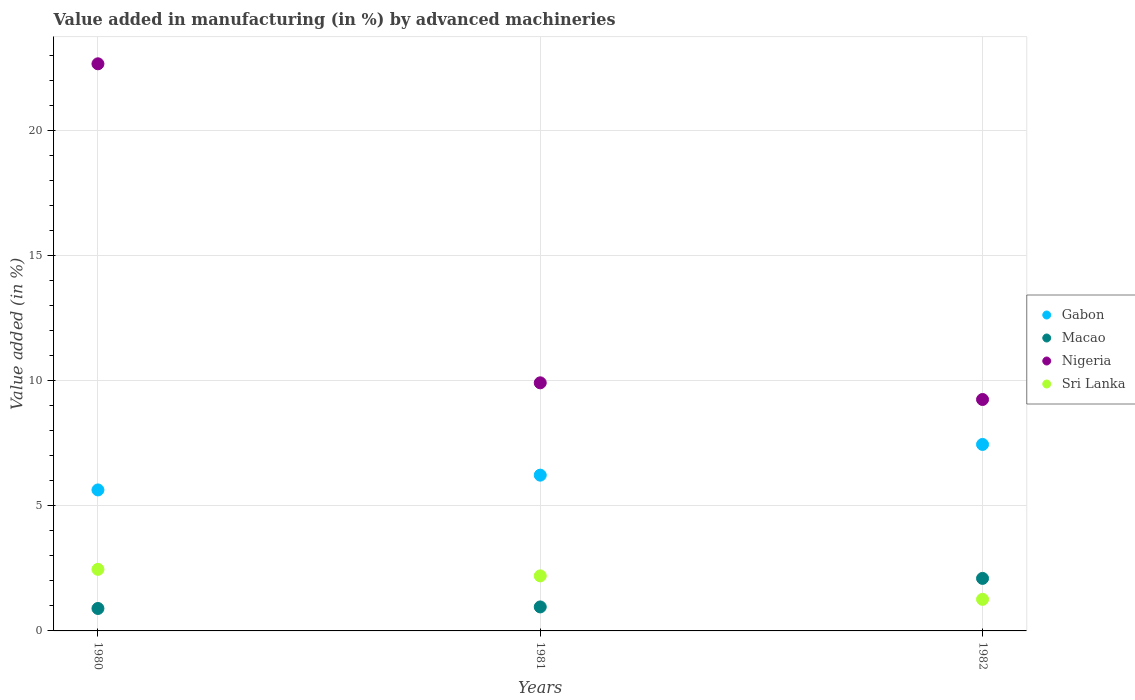How many different coloured dotlines are there?
Offer a terse response. 4. What is the percentage of value added in manufacturing by advanced machineries in Nigeria in 1981?
Provide a short and direct response. 9.91. Across all years, what is the maximum percentage of value added in manufacturing by advanced machineries in Gabon?
Offer a very short reply. 7.45. Across all years, what is the minimum percentage of value added in manufacturing by advanced machineries in Nigeria?
Keep it short and to the point. 9.24. What is the total percentage of value added in manufacturing by advanced machineries in Gabon in the graph?
Offer a terse response. 19.3. What is the difference between the percentage of value added in manufacturing by advanced machineries in Sri Lanka in 1980 and that in 1982?
Your answer should be compact. 1.2. What is the difference between the percentage of value added in manufacturing by advanced machineries in Sri Lanka in 1980 and the percentage of value added in manufacturing by advanced machineries in Macao in 1982?
Your answer should be compact. 0.36. What is the average percentage of value added in manufacturing by advanced machineries in Gabon per year?
Offer a very short reply. 6.43. In the year 1982, what is the difference between the percentage of value added in manufacturing by advanced machineries in Nigeria and percentage of value added in manufacturing by advanced machineries in Macao?
Keep it short and to the point. 7.15. In how many years, is the percentage of value added in manufacturing by advanced machineries in Nigeria greater than 1 %?
Offer a terse response. 3. What is the ratio of the percentage of value added in manufacturing by advanced machineries in Gabon in 1980 to that in 1982?
Offer a very short reply. 0.76. Is the percentage of value added in manufacturing by advanced machineries in Macao in 1981 less than that in 1982?
Give a very brief answer. Yes. What is the difference between the highest and the second highest percentage of value added in manufacturing by advanced machineries in Sri Lanka?
Ensure brevity in your answer.  0.26. What is the difference between the highest and the lowest percentage of value added in manufacturing by advanced machineries in Sri Lanka?
Make the answer very short. 1.2. In how many years, is the percentage of value added in manufacturing by advanced machineries in Macao greater than the average percentage of value added in manufacturing by advanced machineries in Macao taken over all years?
Provide a succinct answer. 1. Is the sum of the percentage of value added in manufacturing by advanced machineries in Macao in 1981 and 1982 greater than the maximum percentage of value added in manufacturing by advanced machineries in Gabon across all years?
Keep it short and to the point. No. Is it the case that in every year, the sum of the percentage of value added in manufacturing by advanced machineries in Gabon and percentage of value added in manufacturing by advanced machineries in Sri Lanka  is greater than the sum of percentage of value added in manufacturing by advanced machineries in Macao and percentage of value added in manufacturing by advanced machineries in Nigeria?
Offer a very short reply. Yes. Is the percentage of value added in manufacturing by advanced machineries in Macao strictly greater than the percentage of value added in manufacturing by advanced machineries in Nigeria over the years?
Keep it short and to the point. No. Is the percentage of value added in manufacturing by advanced machineries in Macao strictly less than the percentage of value added in manufacturing by advanced machineries in Nigeria over the years?
Offer a very short reply. Yes. How many years are there in the graph?
Keep it short and to the point. 3. Does the graph contain any zero values?
Make the answer very short. No. Where does the legend appear in the graph?
Ensure brevity in your answer.  Center right. How many legend labels are there?
Keep it short and to the point. 4. What is the title of the graph?
Keep it short and to the point. Value added in manufacturing (in %) by advanced machineries. What is the label or title of the X-axis?
Provide a short and direct response. Years. What is the label or title of the Y-axis?
Your answer should be very brief. Value added (in %). What is the Value added (in %) of Gabon in 1980?
Offer a very short reply. 5.63. What is the Value added (in %) in Macao in 1980?
Provide a short and direct response. 0.9. What is the Value added (in %) in Nigeria in 1980?
Your answer should be very brief. 22.65. What is the Value added (in %) in Sri Lanka in 1980?
Provide a succinct answer. 2.46. What is the Value added (in %) of Gabon in 1981?
Your response must be concise. 6.22. What is the Value added (in %) of Macao in 1981?
Your answer should be compact. 0.96. What is the Value added (in %) in Nigeria in 1981?
Provide a short and direct response. 9.91. What is the Value added (in %) of Sri Lanka in 1981?
Offer a terse response. 2.2. What is the Value added (in %) of Gabon in 1982?
Your answer should be compact. 7.45. What is the Value added (in %) in Macao in 1982?
Offer a terse response. 2.1. What is the Value added (in %) of Nigeria in 1982?
Keep it short and to the point. 9.24. What is the Value added (in %) in Sri Lanka in 1982?
Provide a short and direct response. 1.26. Across all years, what is the maximum Value added (in %) in Gabon?
Provide a short and direct response. 7.45. Across all years, what is the maximum Value added (in %) of Macao?
Make the answer very short. 2.1. Across all years, what is the maximum Value added (in %) of Nigeria?
Provide a short and direct response. 22.65. Across all years, what is the maximum Value added (in %) in Sri Lanka?
Give a very brief answer. 2.46. Across all years, what is the minimum Value added (in %) of Gabon?
Provide a succinct answer. 5.63. Across all years, what is the minimum Value added (in %) of Macao?
Make the answer very short. 0.9. Across all years, what is the minimum Value added (in %) of Nigeria?
Offer a terse response. 9.24. Across all years, what is the minimum Value added (in %) in Sri Lanka?
Offer a terse response. 1.26. What is the total Value added (in %) in Gabon in the graph?
Keep it short and to the point. 19.3. What is the total Value added (in %) of Macao in the graph?
Your answer should be compact. 3.95. What is the total Value added (in %) in Nigeria in the graph?
Make the answer very short. 41.81. What is the total Value added (in %) of Sri Lanka in the graph?
Provide a succinct answer. 5.92. What is the difference between the Value added (in %) in Gabon in 1980 and that in 1981?
Your answer should be very brief. -0.59. What is the difference between the Value added (in %) of Macao in 1980 and that in 1981?
Provide a succinct answer. -0.06. What is the difference between the Value added (in %) in Nigeria in 1980 and that in 1981?
Offer a very short reply. 12.74. What is the difference between the Value added (in %) in Sri Lanka in 1980 and that in 1981?
Offer a terse response. 0.26. What is the difference between the Value added (in %) in Gabon in 1980 and that in 1982?
Offer a terse response. -1.82. What is the difference between the Value added (in %) of Macao in 1980 and that in 1982?
Ensure brevity in your answer.  -1.2. What is the difference between the Value added (in %) in Nigeria in 1980 and that in 1982?
Keep it short and to the point. 13.41. What is the difference between the Value added (in %) in Sri Lanka in 1980 and that in 1982?
Give a very brief answer. 1.2. What is the difference between the Value added (in %) of Gabon in 1981 and that in 1982?
Your answer should be very brief. -1.23. What is the difference between the Value added (in %) in Macao in 1981 and that in 1982?
Keep it short and to the point. -1.14. What is the difference between the Value added (in %) in Nigeria in 1981 and that in 1982?
Provide a short and direct response. 0.67. What is the difference between the Value added (in %) in Sri Lanka in 1981 and that in 1982?
Your answer should be compact. 0.94. What is the difference between the Value added (in %) of Gabon in 1980 and the Value added (in %) of Macao in 1981?
Make the answer very short. 4.67. What is the difference between the Value added (in %) of Gabon in 1980 and the Value added (in %) of Nigeria in 1981?
Give a very brief answer. -4.28. What is the difference between the Value added (in %) of Gabon in 1980 and the Value added (in %) of Sri Lanka in 1981?
Your response must be concise. 3.43. What is the difference between the Value added (in %) of Macao in 1980 and the Value added (in %) of Nigeria in 1981?
Make the answer very short. -9.01. What is the difference between the Value added (in %) of Macao in 1980 and the Value added (in %) of Sri Lanka in 1981?
Offer a terse response. -1.3. What is the difference between the Value added (in %) of Nigeria in 1980 and the Value added (in %) of Sri Lanka in 1981?
Keep it short and to the point. 20.45. What is the difference between the Value added (in %) of Gabon in 1980 and the Value added (in %) of Macao in 1982?
Your answer should be compact. 3.53. What is the difference between the Value added (in %) in Gabon in 1980 and the Value added (in %) in Nigeria in 1982?
Your answer should be very brief. -3.61. What is the difference between the Value added (in %) of Gabon in 1980 and the Value added (in %) of Sri Lanka in 1982?
Offer a very short reply. 4.37. What is the difference between the Value added (in %) of Macao in 1980 and the Value added (in %) of Nigeria in 1982?
Your response must be concise. -8.35. What is the difference between the Value added (in %) of Macao in 1980 and the Value added (in %) of Sri Lanka in 1982?
Provide a succinct answer. -0.36. What is the difference between the Value added (in %) in Nigeria in 1980 and the Value added (in %) in Sri Lanka in 1982?
Provide a succinct answer. 21.39. What is the difference between the Value added (in %) in Gabon in 1981 and the Value added (in %) in Macao in 1982?
Provide a short and direct response. 4.12. What is the difference between the Value added (in %) in Gabon in 1981 and the Value added (in %) in Nigeria in 1982?
Provide a succinct answer. -3.02. What is the difference between the Value added (in %) in Gabon in 1981 and the Value added (in %) in Sri Lanka in 1982?
Offer a very short reply. 4.96. What is the difference between the Value added (in %) of Macao in 1981 and the Value added (in %) of Nigeria in 1982?
Provide a short and direct response. -8.29. What is the difference between the Value added (in %) in Macao in 1981 and the Value added (in %) in Sri Lanka in 1982?
Keep it short and to the point. -0.3. What is the difference between the Value added (in %) in Nigeria in 1981 and the Value added (in %) in Sri Lanka in 1982?
Provide a succinct answer. 8.65. What is the average Value added (in %) of Gabon per year?
Make the answer very short. 6.43. What is the average Value added (in %) in Macao per year?
Give a very brief answer. 1.32. What is the average Value added (in %) of Nigeria per year?
Keep it short and to the point. 13.94. What is the average Value added (in %) of Sri Lanka per year?
Your answer should be very brief. 1.97. In the year 1980, what is the difference between the Value added (in %) in Gabon and Value added (in %) in Macao?
Ensure brevity in your answer.  4.73. In the year 1980, what is the difference between the Value added (in %) in Gabon and Value added (in %) in Nigeria?
Your answer should be compact. -17.02. In the year 1980, what is the difference between the Value added (in %) of Gabon and Value added (in %) of Sri Lanka?
Ensure brevity in your answer.  3.17. In the year 1980, what is the difference between the Value added (in %) in Macao and Value added (in %) in Nigeria?
Offer a very short reply. -21.76. In the year 1980, what is the difference between the Value added (in %) of Macao and Value added (in %) of Sri Lanka?
Provide a succinct answer. -1.56. In the year 1980, what is the difference between the Value added (in %) of Nigeria and Value added (in %) of Sri Lanka?
Provide a short and direct response. 20.19. In the year 1981, what is the difference between the Value added (in %) in Gabon and Value added (in %) in Macao?
Provide a short and direct response. 5.26. In the year 1981, what is the difference between the Value added (in %) in Gabon and Value added (in %) in Nigeria?
Keep it short and to the point. -3.69. In the year 1981, what is the difference between the Value added (in %) of Gabon and Value added (in %) of Sri Lanka?
Ensure brevity in your answer.  4.02. In the year 1981, what is the difference between the Value added (in %) of Macao and Value added (in %) of Nigeria?
Offer a very short reply. -8.95. In the year 1981, what is the difference between the Value added (in %) in Macao and Value added (in %) in Sri Lanka?
Your answer should be very brief. -1.24. In the year 1981, what is the difference between the Value added (in %) of Nigeria and Value added (in %) of Sri Lanka?
Provide a succinct answer. 7.71. In the year 1982, what is the difference between the Value added (in %) in Gabon and Value added (in %) in Macao?
Give a very brief answer. 5.35. In the year 1982, what is the difference between the Value added (in %) of Gabon and Value added (in %) of Nigeria?
Your answer should be compact. -1.8. In the year 1982, what is the difference between the Value added (in %) of Gabon and Value added (in %) of Sri Lanka?
Ensure brevity in your answer.  6.19. In the year 1982, what is the difference between the Value added (in %) of Macao and Value added (in %) of Nigeria?
Offer a terse response. -7.15. In the year 1982, what is the difference between the Value added (in %) in Macao and Value added (in %) in Sri Lanka?
Make the answer very short. 0.84. In the year 1982, what is the difference between the Value added (in %) of Nigeria and Value added (in %) of Sri Lanka?
Offer a terse response. 7.98. What is the ratio of the Value added (in %) in Gabon in 1980 to that in 1981?
Offer a very short reply. 0.91. What is the ratio of the Value added (in %) of Macao in 1980 to that in 1981?
Offer a very short reply. 0.94. What is the ratio of the Value added (in %) in Nigeria in 1980 to that in 1981?
Offer a very short reply. 2.29. What is the ratio of the Value added (in %) in Sri Lanka in 1980 to that in 1981?
Your answer should be compact. 1.12. What is the ratio of the Value added (in %) in Gabon in 1980 to that in 1982?
Offer a very short reply. 0.76. What is the ratio of the Value added (in %) of Macao in 1980 to that in 1982?
Your response must be concise. 0.43. What is the ratio of the Value added (in %) in Nigeria in 1980 to that in 1982?
Ensure brevity in your answer.  2.45. What is the ratio of the Value added (in %) in Sri Lanka in 1980 to that in 1982?
Provide a short and direct response. 1.95. What is the ratio of the Value added (in %) in Gabon in 1981 to that in 1982?
Offer a terse response. 0.84. What is the ratio of the Value added (in %) of Macao in 1981 to that in 1982?
Make the answer very short. 0.46. What is the ratio of the Value added (in %) in Nigeria in 1981 to that in 1982?
Offer a terse response. 1.07. What is the ratio of the Value added (in %) in Sri Lanka in 1981 to that in 1982?
Keep it short and to the point. 1.74. What is the difference between the highest and the second highest Value added (in %) in Gabon?
Give a very brief answer. 1.23. What is the difference between the highest and the second highest Value added (in %) in Macao?
Keep it short and to the point. 1.14. What is the difference between the highest and the second highest Value added (in %) of Nigeria?
Provide a short and direct response. 12.74. What is the difference between the highest and the second highest Value added (in %) in Sri Lanka?
Provide a succinct answer. 0.26. What is the difference between the highest and the lowest Value added (in %) of Gabon?
Your answer should be very brief. 1.82. What is the difference between the highest and the lowest Value added (in %) of Macao?
Offer a very short reply. 1.2. What is the difference between the highest and the lowest Value added (in %) of Nigeria?
Offer a very short reply. 13.41. What is the difference between the highest and the lowest Value added (in %) in Sri Lanka?
Provide a succinct answer. 1.2. 